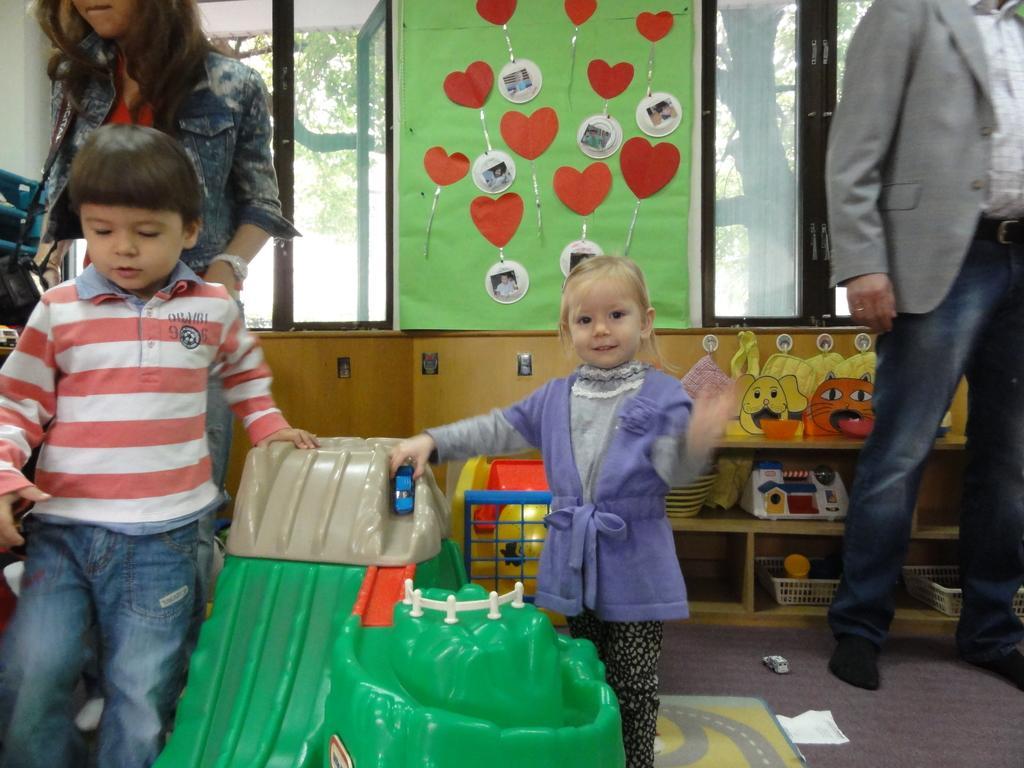Can you describe this image briefly? There are children playing with toys. In the back there is a man. Also there is a lady holding something. In the background there are windows. There are toys. On the wall there are some decorative items. Also there are cupboards. Inside the cupboards there are some toys. Through the windows we can see trees. 